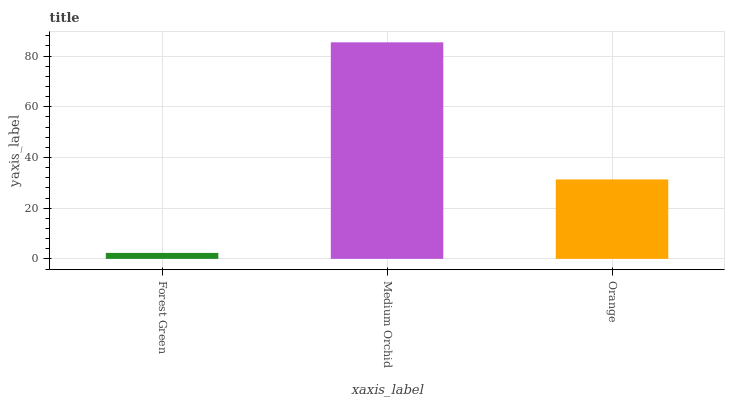Is Forest Green the minimum?
Answer yes or no. Yes. Is Medium Orchid the maximum?
Answer yes or no. Yes. Is Orange the minimum?
Answer yes or no. No. Is Orange the maximum?
Answer yes or no. No. Is Medium Orchid greater than Orange?
Answer yes or no. Yes. Is Orange less than Medium Orchid?
Answer yes or no. Yes. Is Orange greater than Medium Orchid?
Answer yes or no. No. Is Medium Orchid less than Orange?
Answer yes or no. No. Is Orange the high median?
Answer yes or no. Yes. Is Orange the low median?
Answer yes or no. Yes. Is Medium Orchid the high median?
Answer yes or no. No. Is Medium Orchid the low median?
Answer yes or no. No. 